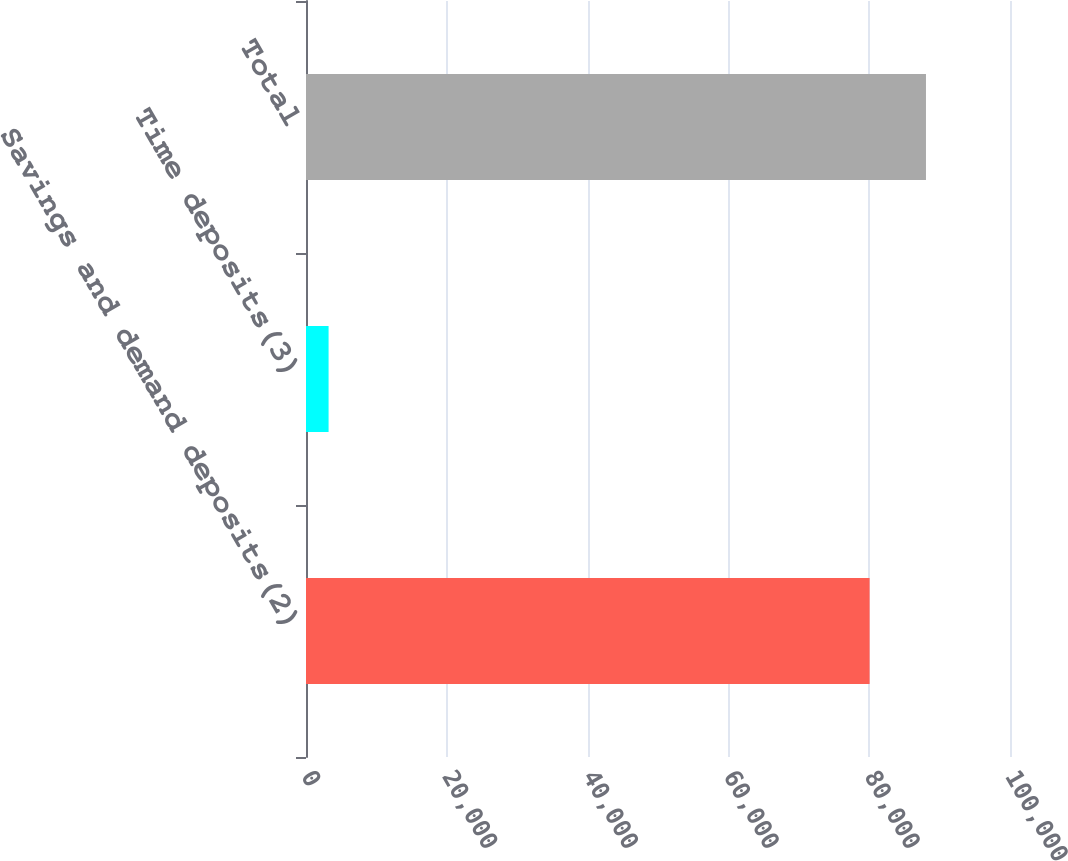Convert chart to OTSL. <chart><loc_0><loc_0><loc_500><loc_500><bar_chart><fcel>Savings and demand deposits(2)<fcel>Time deposits(3)<fcel>Total<nl><fcel>80058<fcel>3208<fcel>88063.8<nl></chart> 